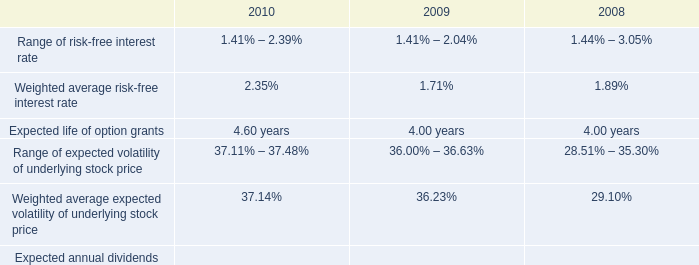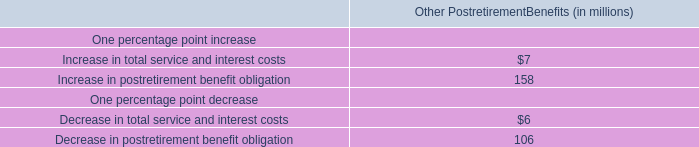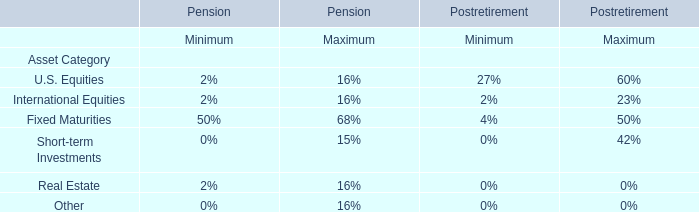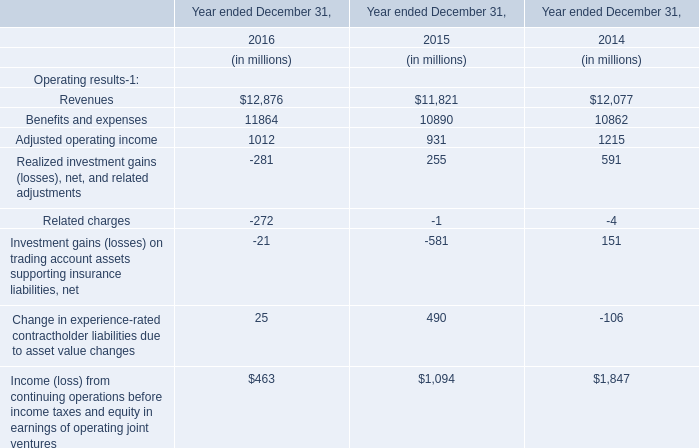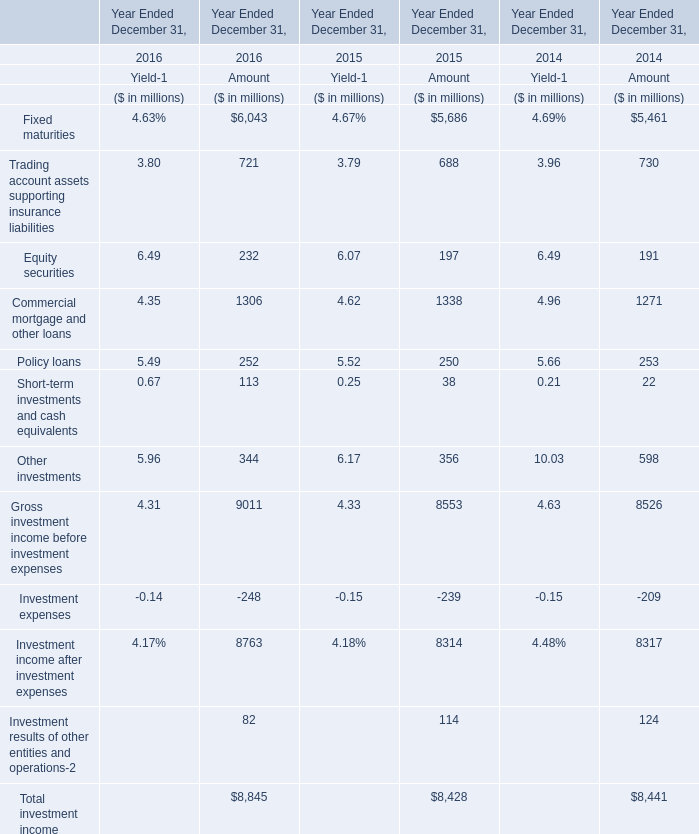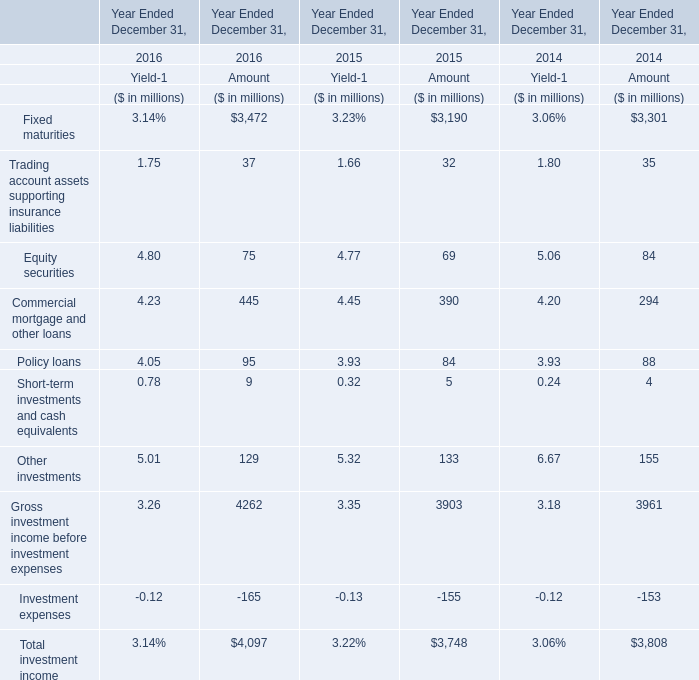What's the current increasing rate of Policy loans for amount? 
Computations: ((95 - 84) / 84)
Answer: 0.13095. 